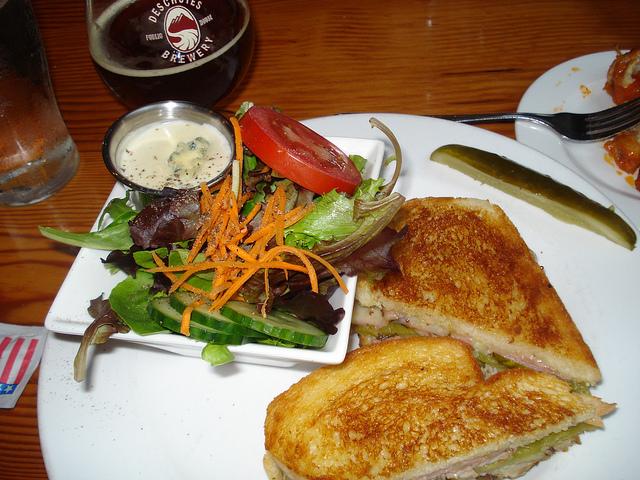How many tomato slices are on the salad?
Be succinct. 1. Is this a fancy or casual meal?
Concise answer only. Casual. Where is the other half of this sandwich?
Be succinct. Next to it. What is the healthiest part of this meal?
Give a very brief answer. Salad. 